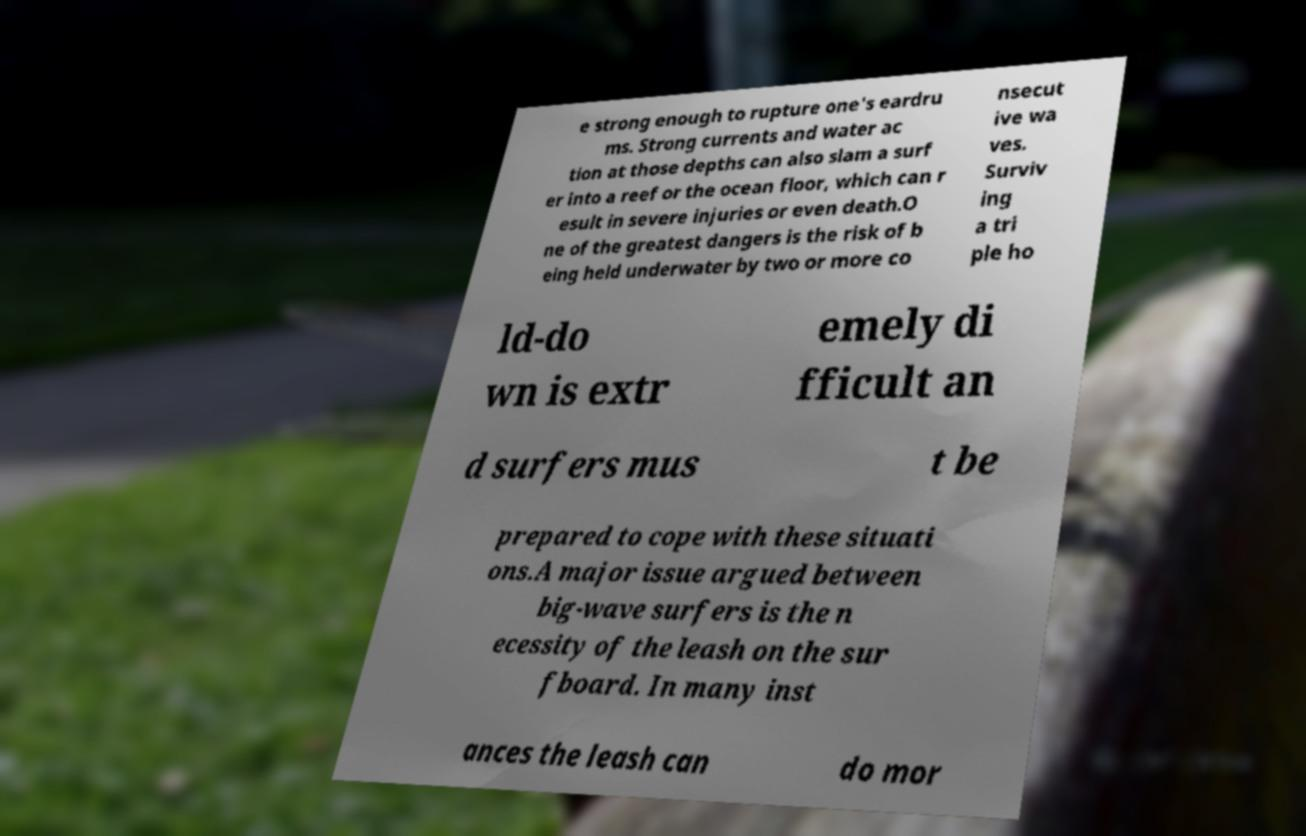Could you extract and type out the text from this image? e strong enough to rupture one's eardru ms. Strong currents and water ac tion at those depths can also slam a surf er into a reef or the ocean floor, which can r esult in severe injuries or even death.O ne of the greatest dangers is the risk of b eing held underwater by two or more co nsecut ive wa ves. Surviv ing a tri ple ho ld-do wn is extr emely di fficult an d surfers mus t be prepared to cope with these situati ons.A major issue argued between big-wave surfers is the n ecessity of the leash on the sur fboard. In many inst ances the leash can do mor 